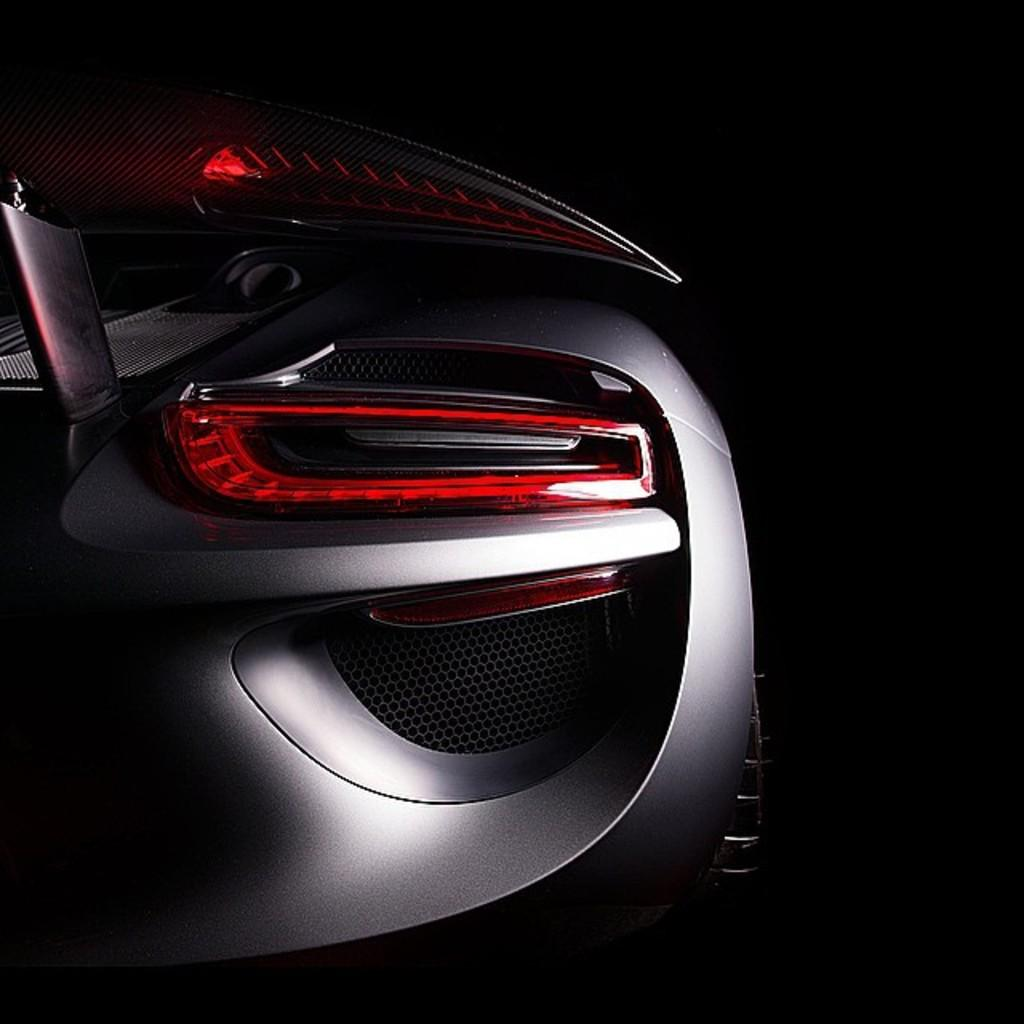What is the main subject of the image? The main subject of the image is the backside of a car. What can be seen behind the car in the image? There is a black color background in the image. Can you see the writer's hand holding a pen in the image? There is no writer or pen present in the image; it shows the backside of a car against a black background. 